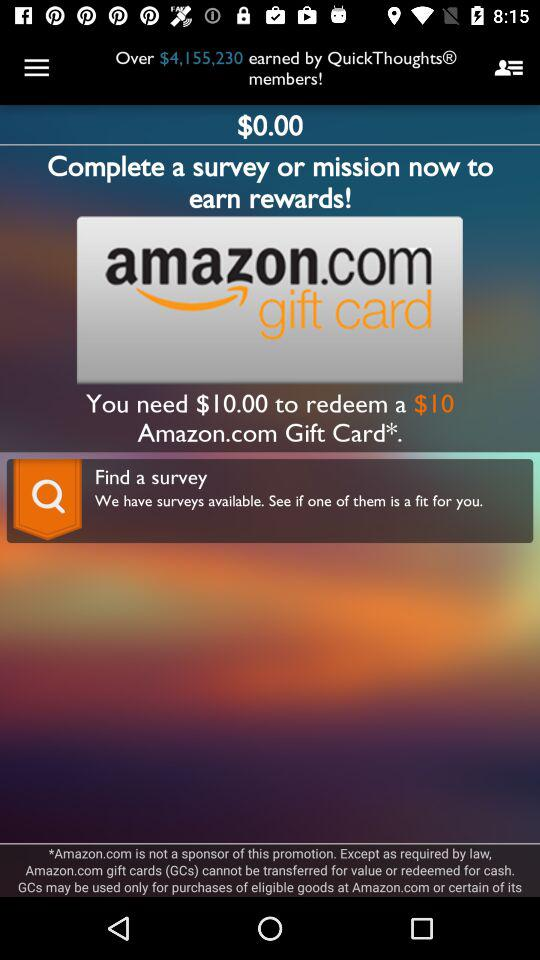How much more do I need to earn to redeem a $10 Amazon.com gift card?
Answer the question using a single word or phrase. $10.00 